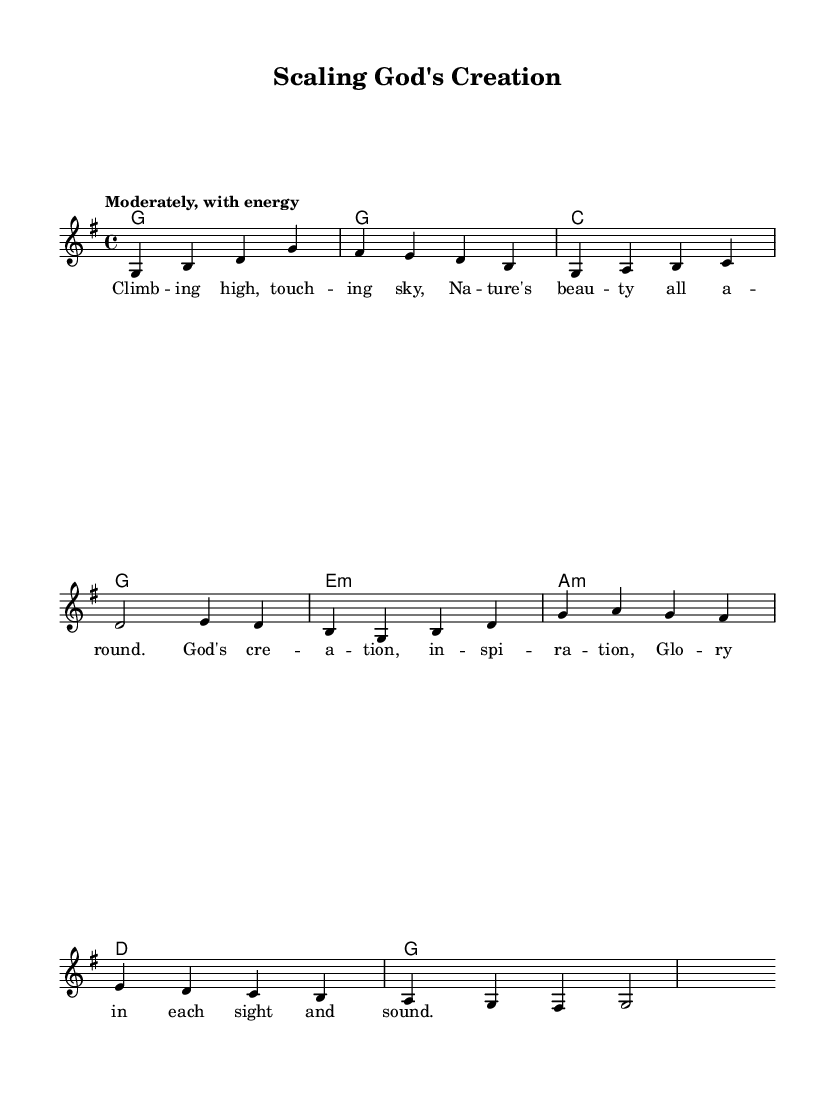What is the key signature of this music? The key signature is G major, which has one sharp (F#). This can be identified by looking at the beginning of the staff where the key signature is placed.
Answer: G major What is the time signature of this music? The time signature is 4/4, indicated at the beginning of the score. This means there are four beats in each measure and the quarter note gets one beat.
Answer: 4/4 What is the tempo marking for this piece? The tempo marking is "Moderately, with energy," which gives performers an idea of how fast to play the music and the energy level intended. This is usually found above the staff at the beginning of the score.
Answer: Moderately, with energy How many measures are in the melody? The melody contains eight measures, which can be counted by looking at the grouping of the notes and the vertical lines separating them.
Answer: 8 What chord follows the G major chord in the harmonic progression? The chord following G major is C major, which is the second chord in the progression shown in the harmonies section. This can be seen in the chord sequences directly above the melody notes.
Answer: C What is the title of the music? The title is "Scaling God's Creation," as indicated in the header section of the score, which typically features the title prominently at the top.
Answer: Scaling God's Creation What theme is celebrated in the lyrics of this piece? The theme in the lyrics celebrates the beauty of nature and creation, as indicated by phrases like "Nature's beauty all around" and "God's creation, inspiration." This is derived from analyzing the words of the verse.
Answer: Beauty of nature and creation 